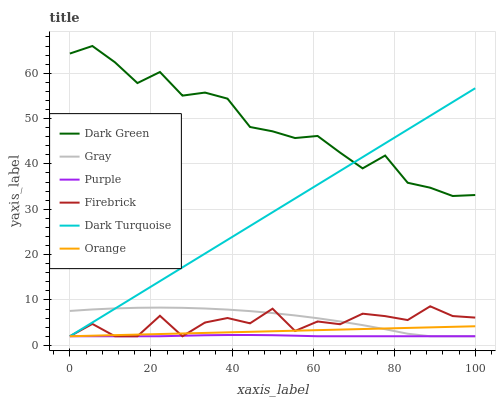Does Purple have the minimum area under the curve?
Answer yes or no. Yes. Does Dark Green have the maximum area under the curve?
Answer yes or no. Yes. Does Dark Turquoise have the minimum area under the curve?
Answer yes or no. No. Does Dark Turquoise have the maximum area under the curve?
Answer yes or no. No. Is Orange the smoothest?
Answer yes or no. Yes. Is Firebrick the roughest?
Answer yes or no. Yes. Is Purple the smoothest?
Answer yes or no. No. Is Purple the roughest?
Answer yes or no. No. Does Dark Green have the lowest value?
Answer yes or no. No. Does Dark Turquoise have the highest value?
Answer yes or no. No. Is Orange less than Dark Green?
Answer yes or no. Yes. Is Dark Green greater than Orange?
Answer yes or no. Yes. Does Orange intersect Dark Green?
Answer yes or no. No. 